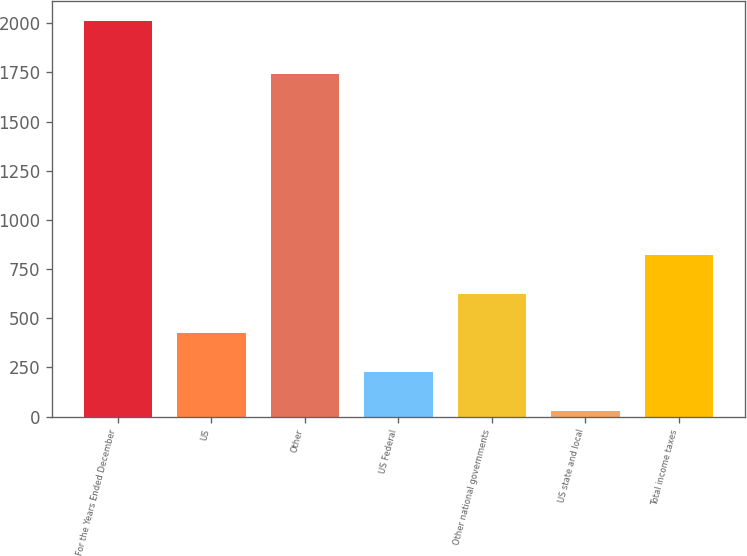Convert chart to OTSL. <chart><loc_0><loc_0><loc_500><loc_500><bar_chart><fcel>For the Years Ended December<fcel>US<fcel>Other<fcel>US Federal<fcel>Other national governments<fcel>US state and local<fcel>Total income taxes<nl><fcel>2014<fcel>423.6<fcel>1744<fcel>224.8<fcel>622.4<fcel>26<fcel>821.2<nl></chart> 